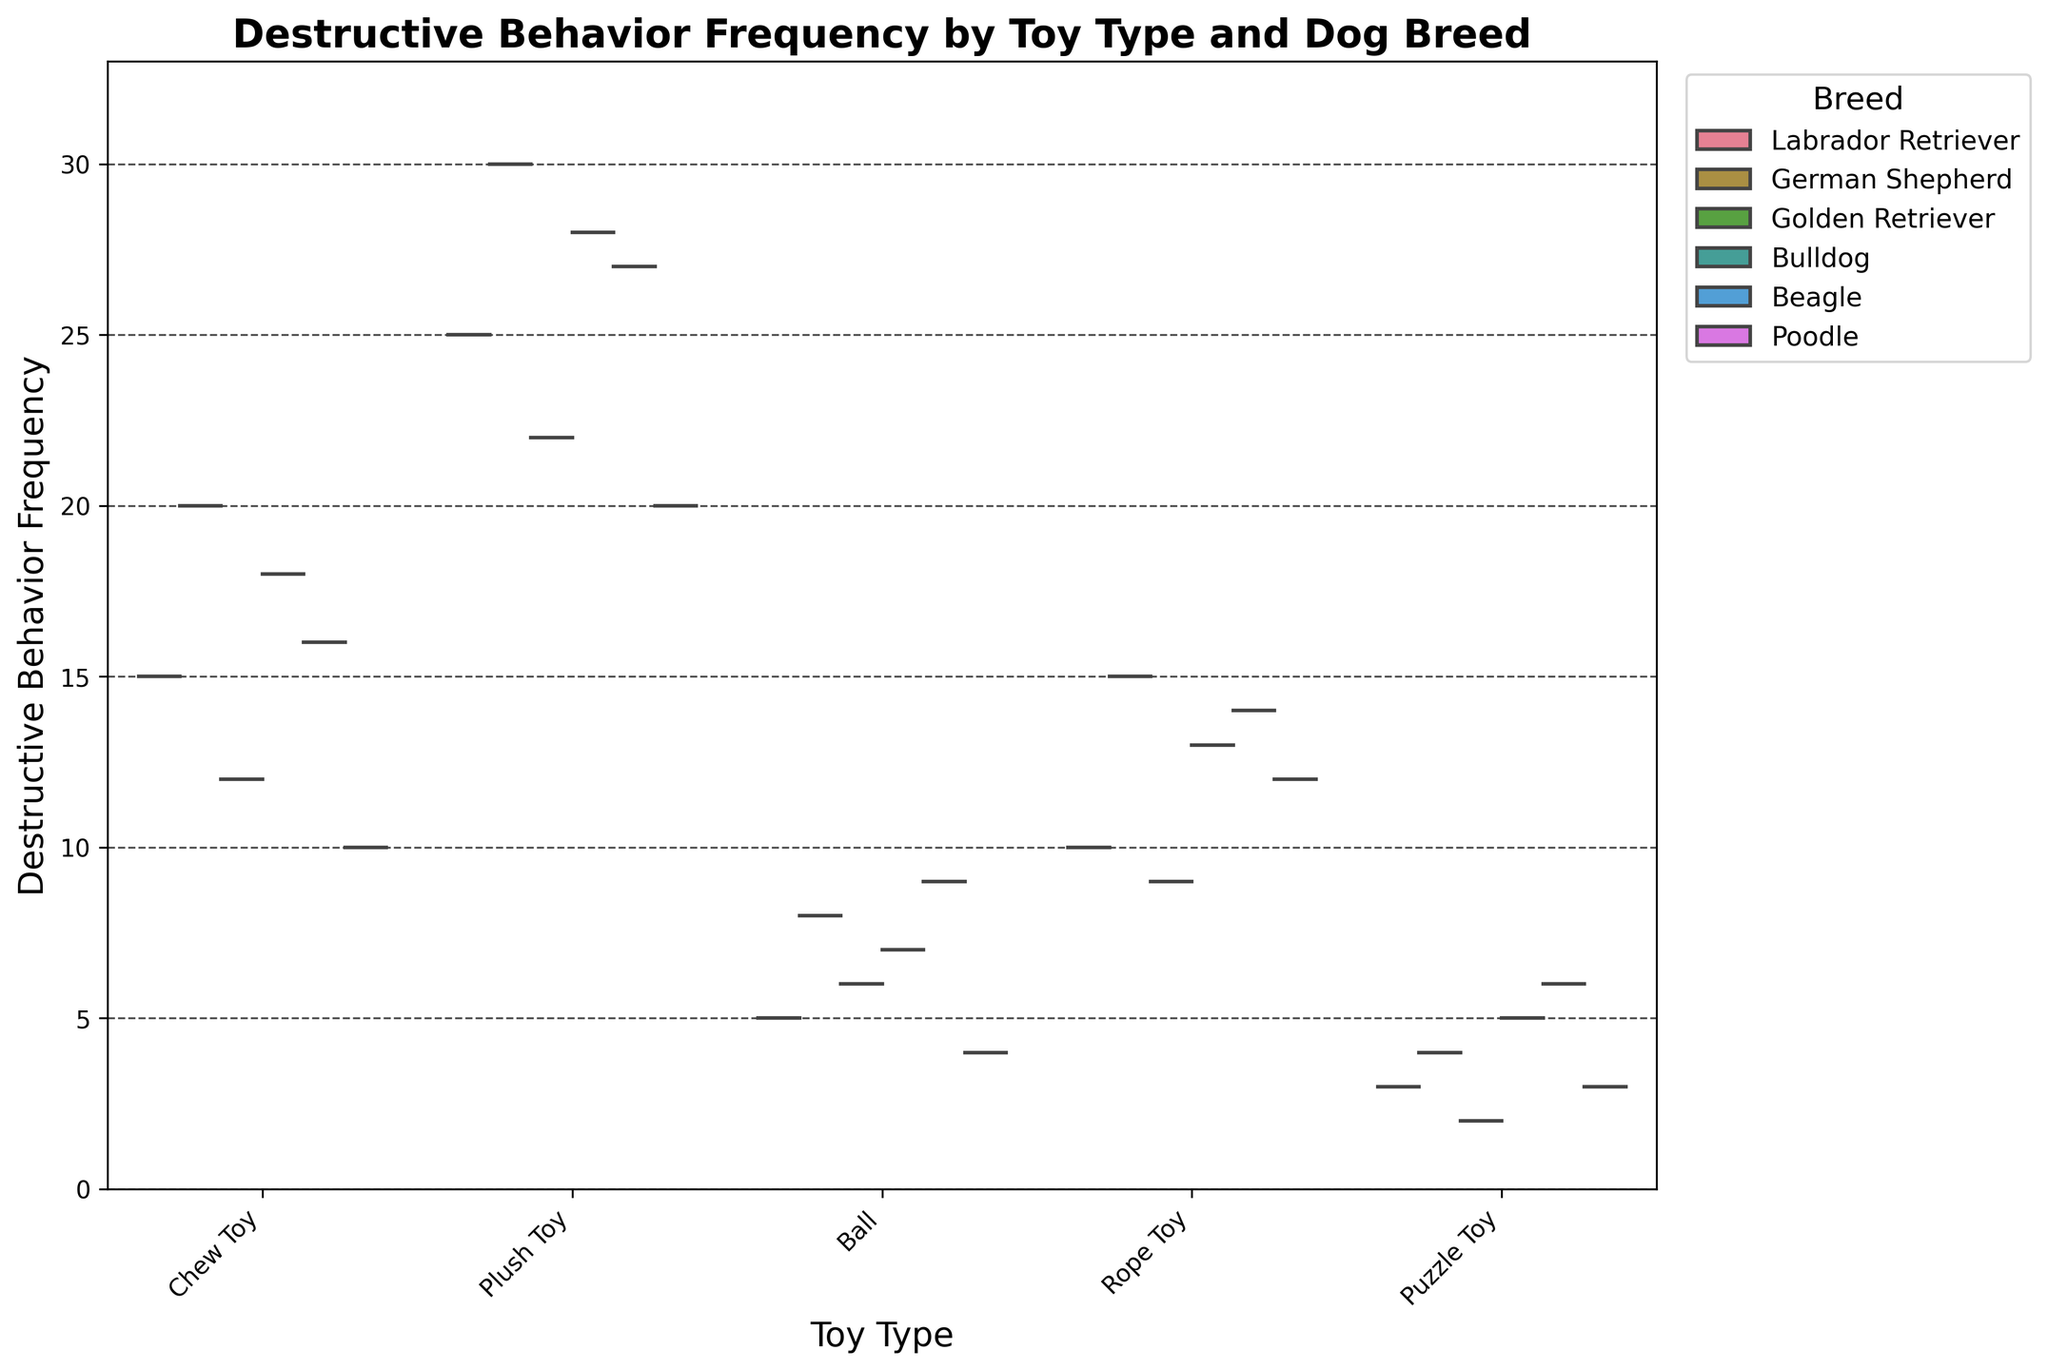How is the title described in the chart? The chart's title is typically displayed at the top. It's an overview of what the figure represents. In this case, it includes the topic, "Destructive Behavior Frequency by Toy Type and Dog Breed".
Answer: Destructive Behavior Frequency by Toy Type and Dog Breed What are the labels for the x and y axes? The x-axis label is found at the bottom and represents the categories being compared (types of toys), while the y-axis label is found at the side and shows what is being measured (destructive behavior frequency).
Answer: Toy Type, Destructive Behavior Frequency What is the range of the y-axis? The y-axis range gives the span of values covered in the graph. According to the data code snippet, the maximum value is scaled to 1.1 times the highest frequency. Since the highest frequency is 30, 30 x 1.1 = 33.
Answer: 0 to 33 Which Toy Type has the highest median destructive behavior frequency for Labradors? By examining the violin plot for the Labrador breed and locating the median line within the distribution, we can identify the toy type with the highest median.
Answer: Plush Toy Among the different breeds, which toy type results in the highest overall maximum destructive behavior frequency? We need to check the highest points in each toy type distribution across all breeds to determine the toy type with the highest maximum frequency.
Answer: Plush Toy Which toy type shows the least variation in destructive behavior frequency for German Shepherds? In a violin plot, variation is viewed as the width of the distribution. Narrower distributions suggest less variation.
Answer: Puzzle Toy How do the destructive behavior frequencies for Beagles compare for Chew Toys vs. Plush Toys? By comparing the width and height of the violin plots for Beagles under Chew Toys and Plush Toys, we can determine how the destructive behaviors differ in frequency.
Answer: Plush Toys show higher frequency and variation Which dog breed demonstrates the lowest destructive behavior frequency for Puzzle Toys? The lowest point on the Puzzle Toys violin plot corresponds to the breed with the minimal frequency. Labrador Retrievers have the lowest plotted point for this toy type.
Answer: Golden Retrievers Which toy type seems equally engaging for both Bulldogs and Beagles in terms of destructive behavior frequency? Toy types with overlapping or similarly shaped distributions for Bulldogs and Beagles in the violin plot suggest equal engagement.
Answer: Rope Toys Does the frequency of destructive behavior for Poodles differ greatly between Ball and Rope Toys? By inspecting the distribution's spread and central tendency for Poodles between these two toy types, any difference or similarity will be evident.
Answer: Yes, Rope Toys have a higher frequency range compared to Balls 